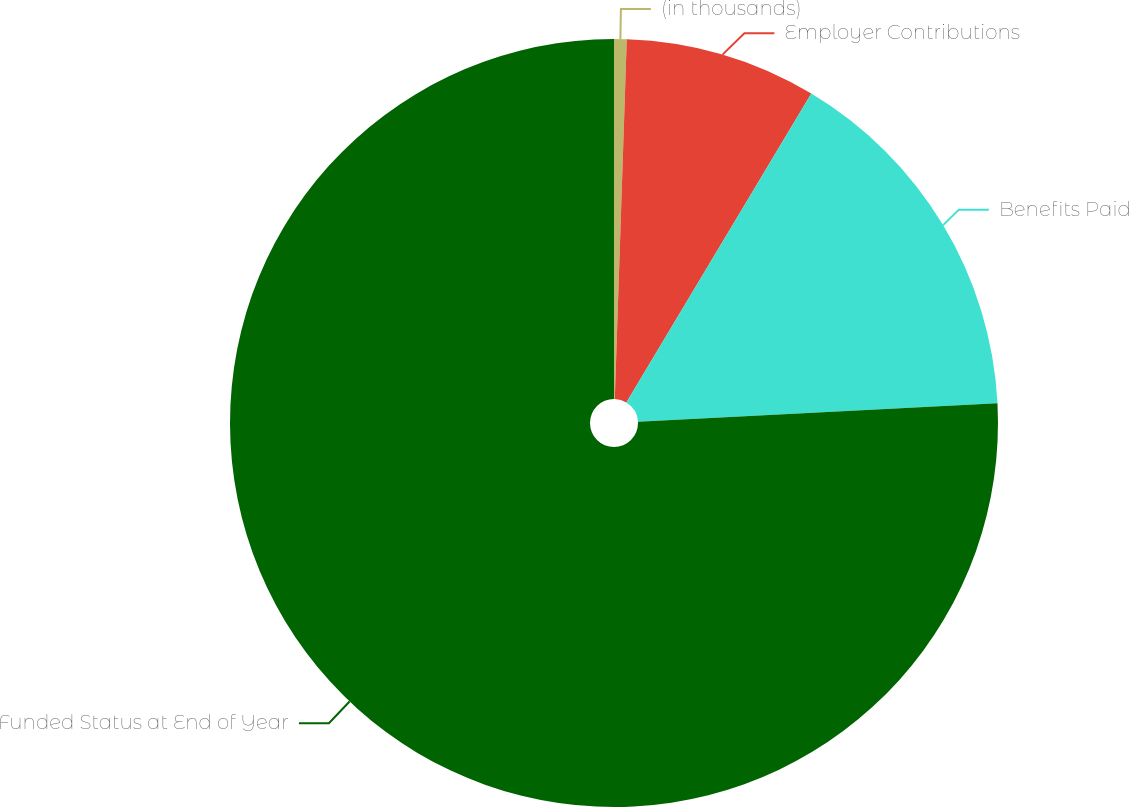Convert chart to OTSL. <chart><loc_0><loc_0><loc_500><loc_500><pie_chart><fcel>(in thousands)<fcel>Employer Contributions<fcel>Benefits Paid<fcel>Funded Status at End of Year<nl><fcel>0.53%<fcel>8.06%<fcel>15.59%<fcel>75.83%<nl></chart> 